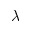<formula> <loc_0><loc_0><loc_500><loc_500>\lambda</formula> 